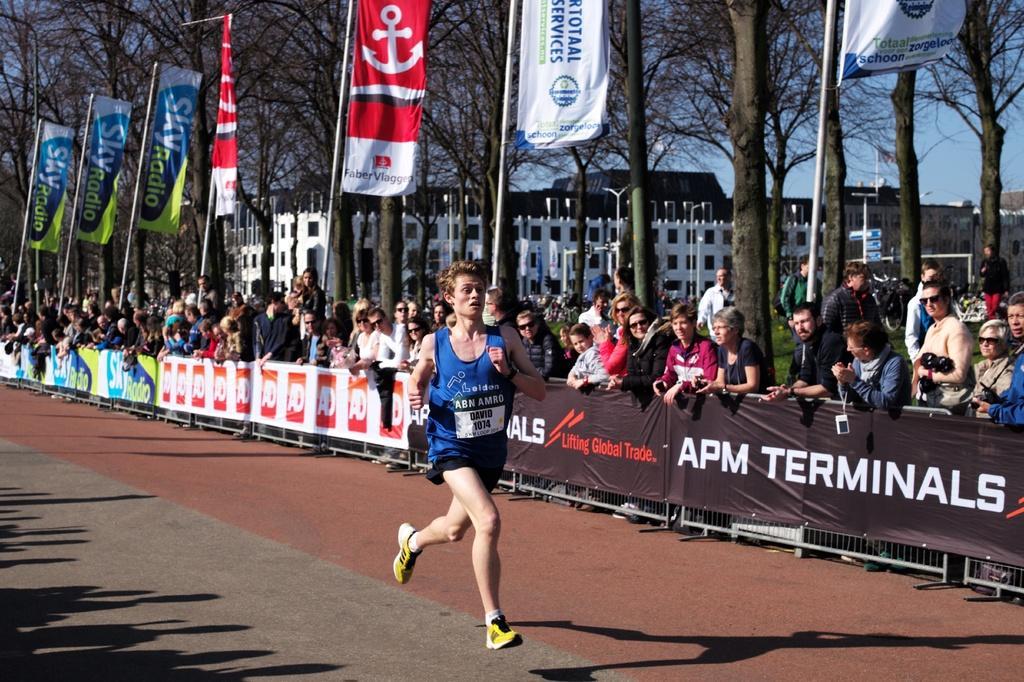How would you summarize this image in a sentence or two? In the middle of the image a person is running. Behind him there is a banner. Behind the banner few people are standing and watching. At the top of the image there are some banners and trees and buildings. 